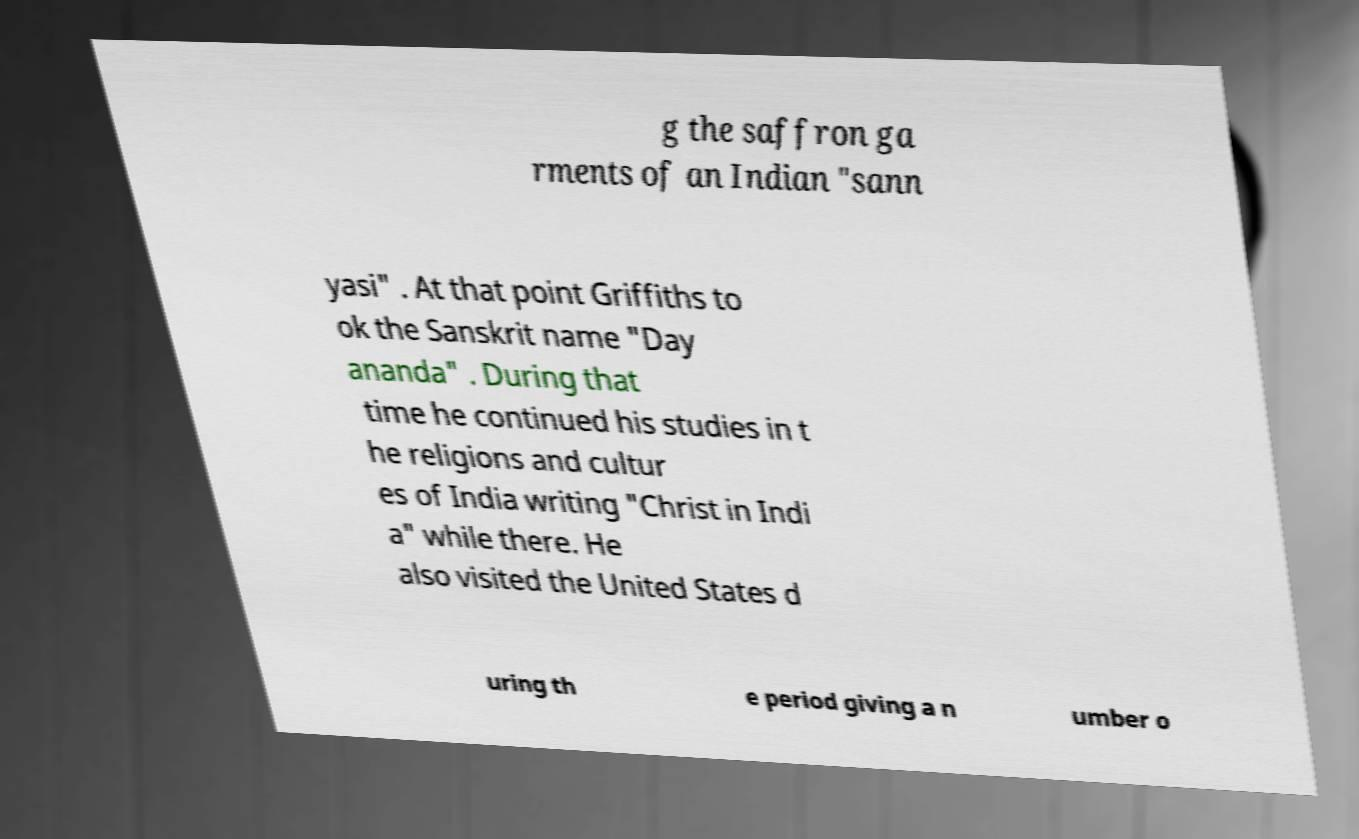Can you accurately transcribe the text from the provided image for me? g the saffron ga rments of an Indian "sann yasi" . At that point Griffiths to ok the Sanskrit name "Day ananda" . During that time he continued his studies in t he religions and cultur es of India writing "Christ in Indi a" while there. He also visited the United States d uring th e period giving a n umber o 